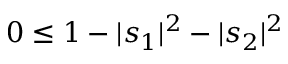Convert formula to latex. <formula><loc_0><loc_0><loc_500><loc_500>0 \leq 1 - | s _ { 1 } | ^ { 2 } - | s _ { 2 } | ^ { 2 }</formula> 